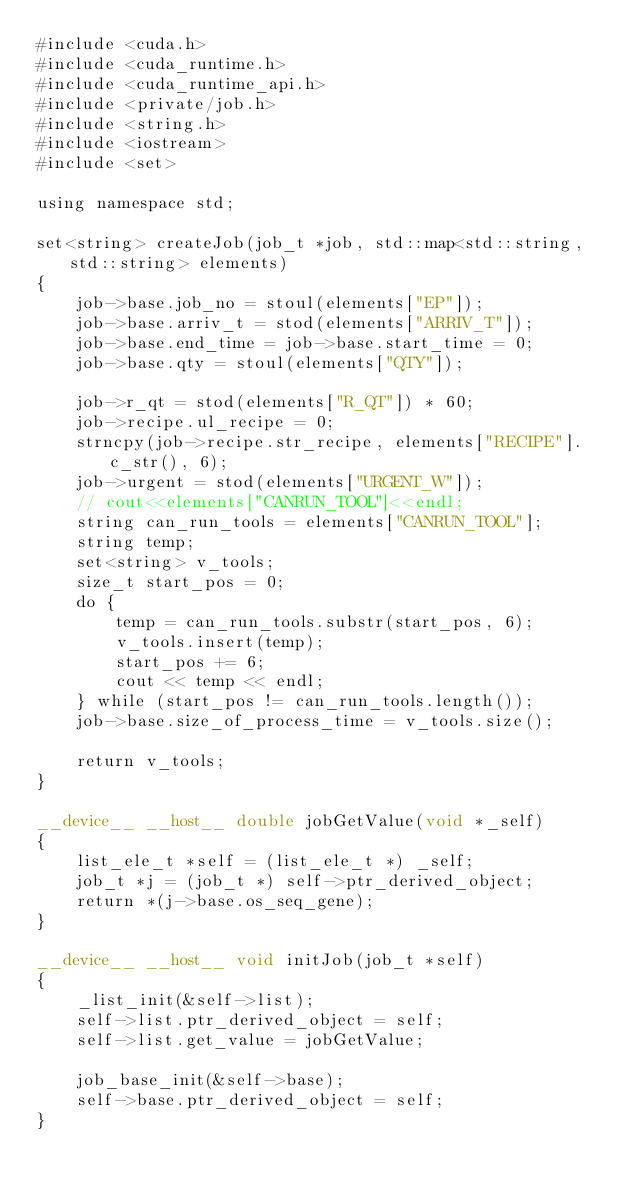Convert code to text. <code><loc_0><loc_0><loc_500><loc_500><_Cuda_>#include <cuda.h>
#include <cuda_runtime.h>
#include <cuda_runtime_api.h>
#include <private/job.h>
#include <string.h>
#include <iostream>
#include <set>

using namespace std;

set<string> createJob(job_t *job, std::map<std::string, std::string> elements)
{
    job->base.job_no = stoul(elements["EP"]);
    job->base.arriv_t = stod(elements["ARRIV_T"]);
    job->base.end_time = job->base.start_time = 0;
    job->base.qty = stoul(elements["QTY"]);

    job->r_qt = stod(elements["R_QT"]) * 60;
    job->recipe.ul_recipe = 0;
    strncpy(job->recipe.str_recipe, elements["RECIPE"].c_str(), 6);
    job->urgent = stod(elements["URGENT_W"]);
    // cout<<elements["CANRUN_TOOL"]<<endl;
    string can_run_tools = elements["CANRUN_TOOL"];
    string temp;
    set<string> v_tools;
    size_t start_pos = 0;
    do {
        temp = can_run_tools.substr(start_pos, 6);
        v_tools.insert(temp);
        start_pos += 6;
        cout << temp << endl;
    } while (start_pos != can_run_tools.length());
    job->base.size_of_process_time = v_tools.size();

    return v_tools;
}

__device__ __host__ double jobGetValue(void *_self)
{
    list_ele_t *self = (list_ele_t *) _self;
    job_t *j = (job_t *) self->ptr_derived_object;
    return *(j->base.os_seq_gene);
}

__device__ __host__ void initJob(job_t *self)
{
    _list_init(&self->list);
    self->list.ptr_derived_object = self;
    self->list.get_value = jobGetValue;

    job_base_init(&self->base);
    self->base.ptr_derived_object = self;
}
</code> 